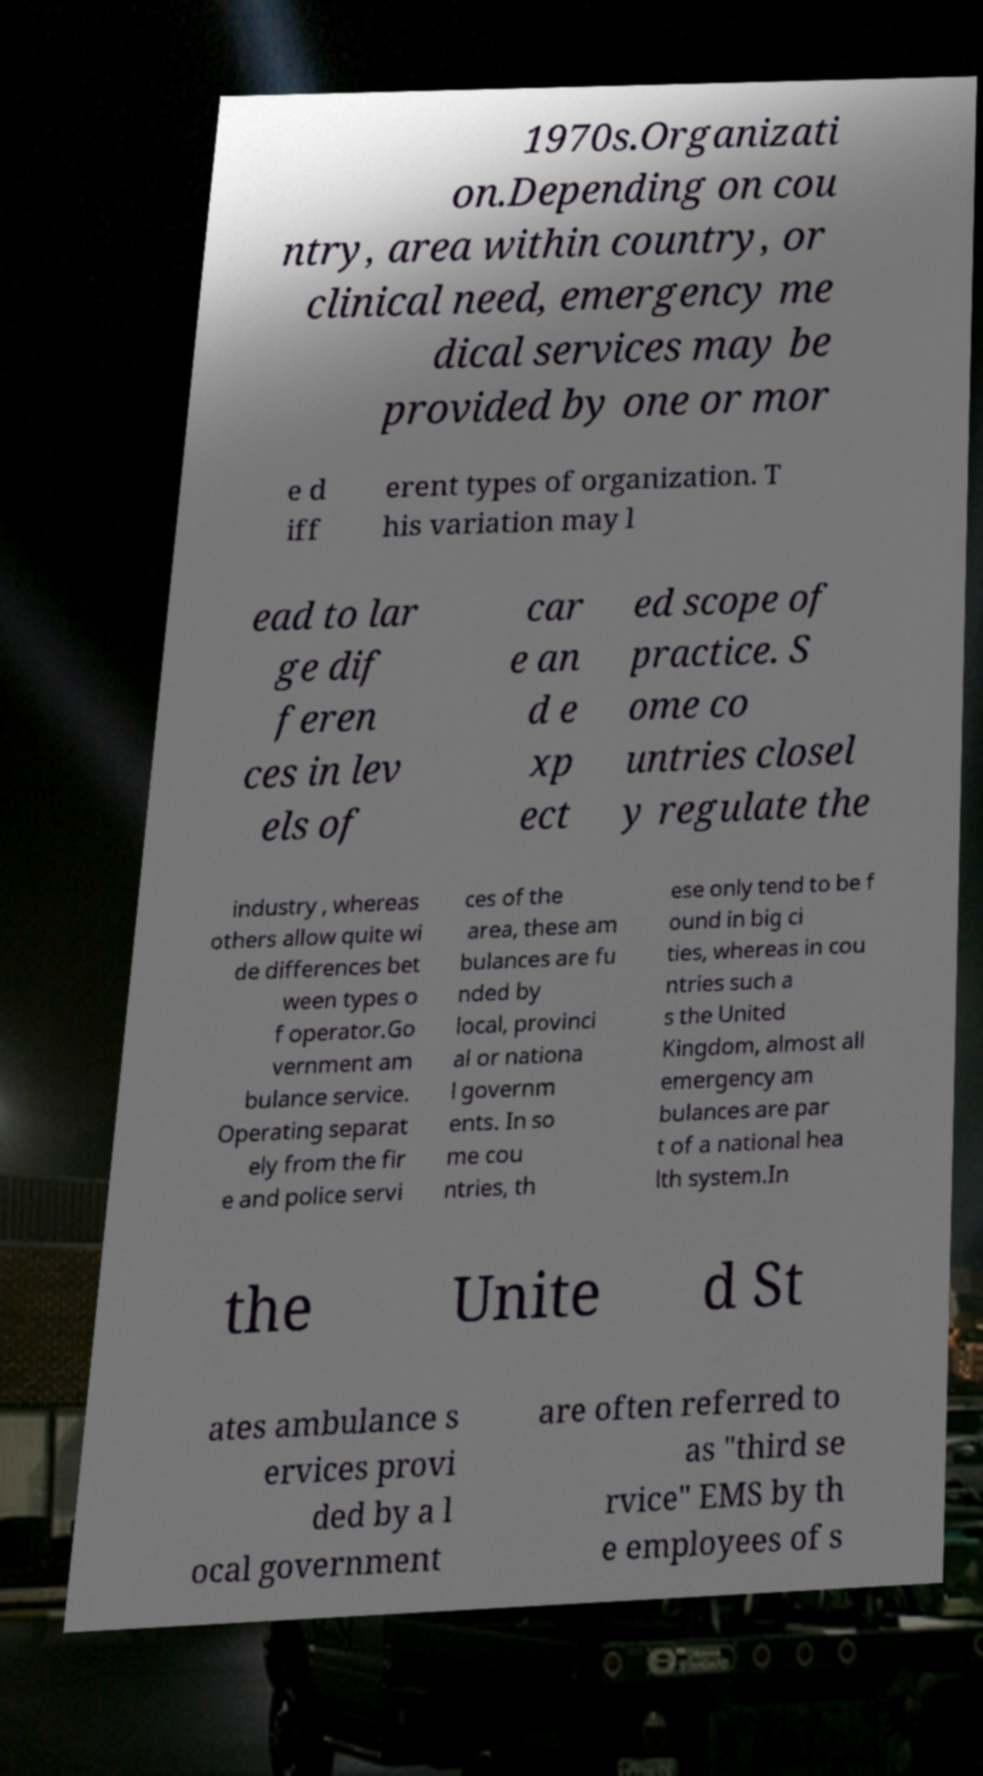For documentation purposes, I need the text within this image transcribed. Could you provide that? 1970s.Organizati on.Depending on cou ntry, area within country, or clinical need, emergency me dical services may be provided by one or mor e d iff erent types of organization. T his variation may l ead to lar ge dif feren ces in lev els of car e an d e xp ect ed scope of practice. S ome co untries closel y regulate the industry , whereas others allow quite wi de differences bet ween types o f operator.Go vernment am bulance service. Operating separat ely from the fir e and police servi ces of the area, these am bulances are fu nded by local, provinci al or nationa l governm ents. In so me cou ntries, th ese only tend to be f ound in big ci ties, whereas in cou ntries such a s the United Kingdom, almost all emergency am bulances are par t of a national hea lth system.In the Unite d St ates ambulance s ervices provi ded by a l ocal government are often referred to as "third se rvice" EMS by th e employees of s 